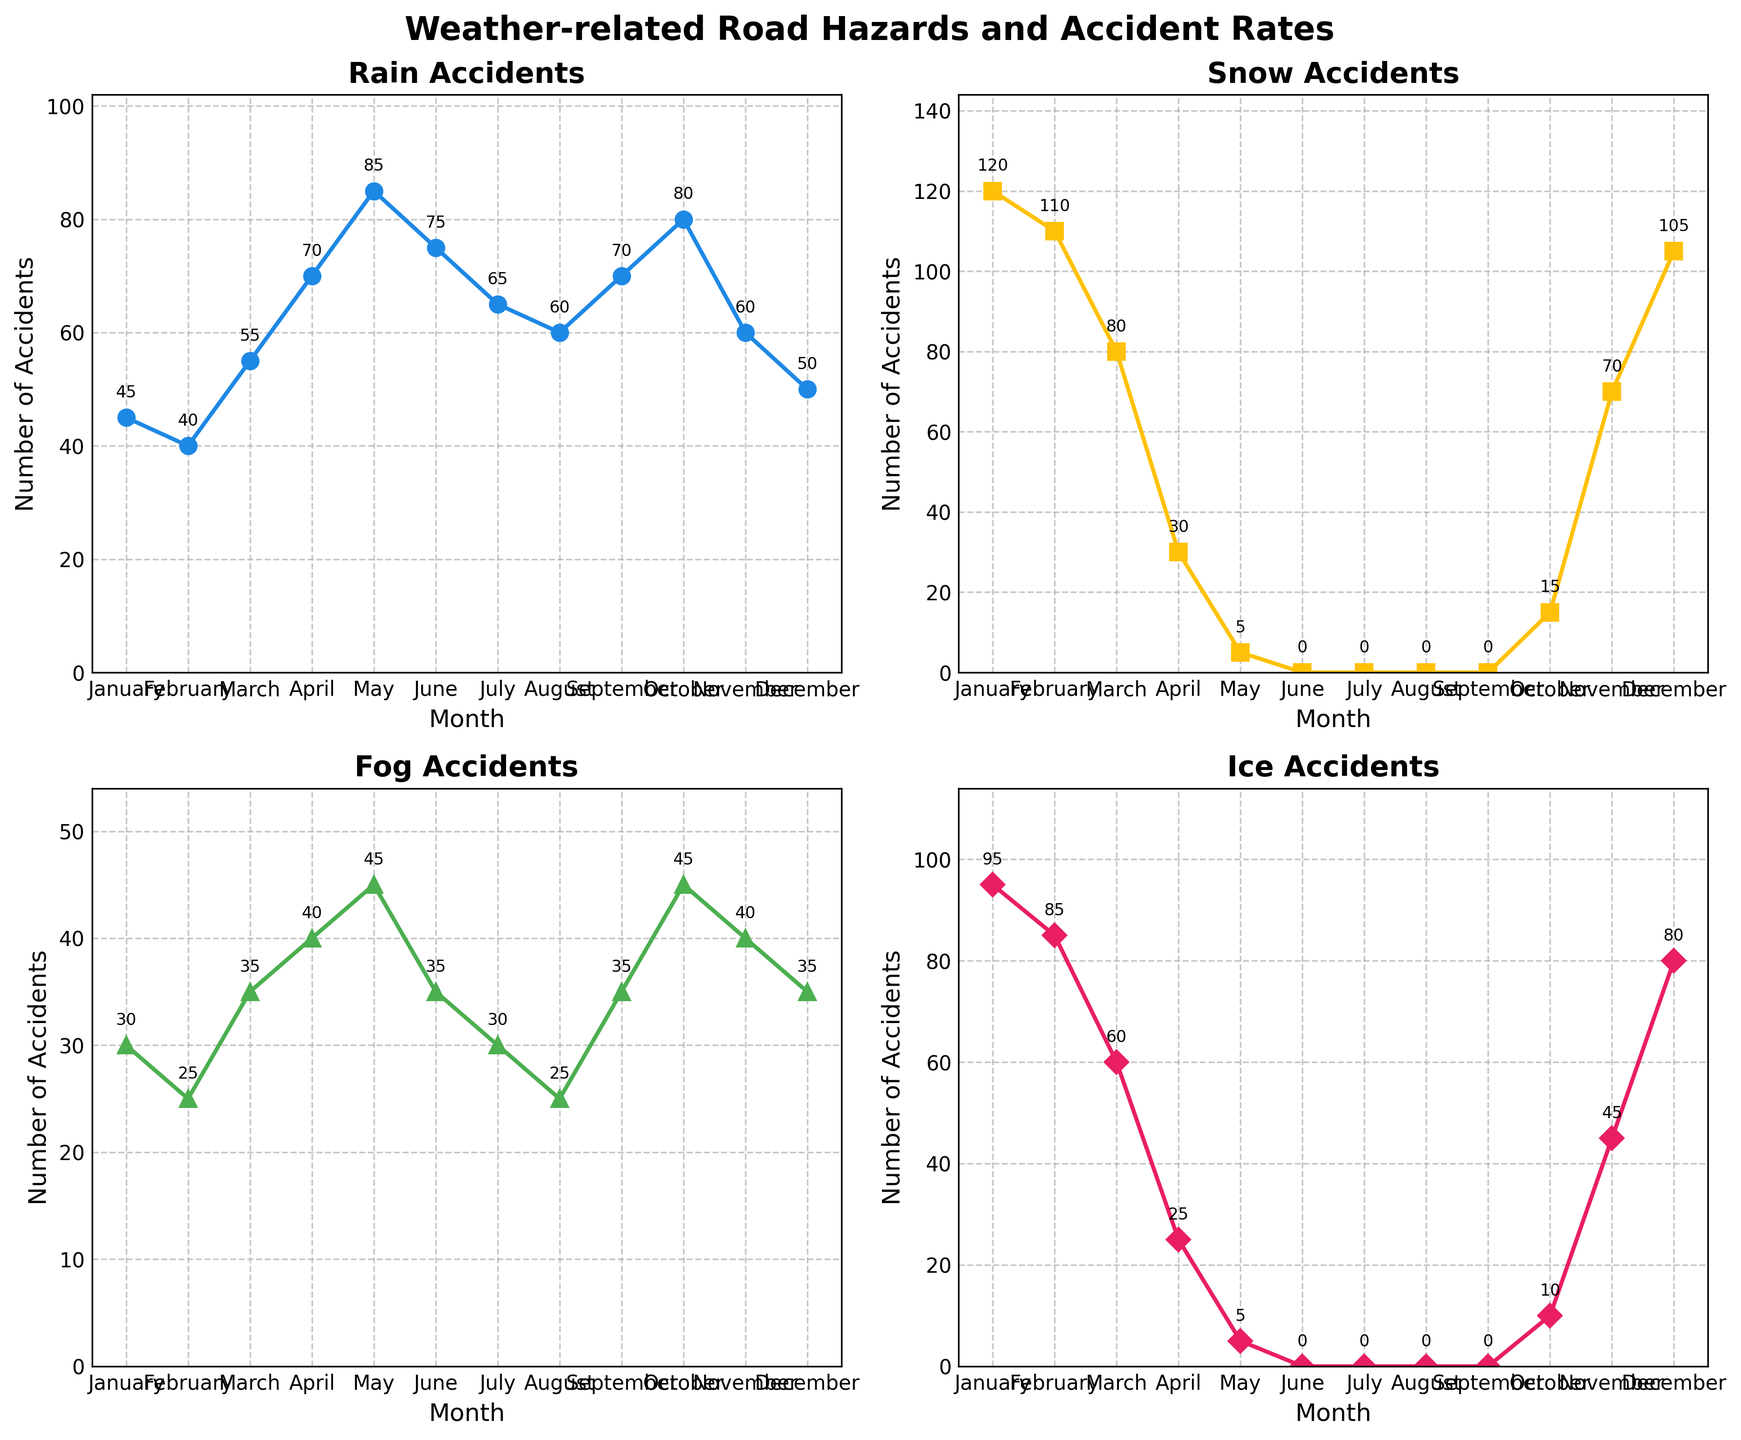What title is given to the figure? The title is written at the top of the figure. It reads "Weather-related Road Hazards and Accident Rates".
Answer: Weather-related Road Hazards and Accident Rates What month has the highest number of snow-related accidents? In the subplot titled "Snow Accidents," the line peaks in January, indicating this month has the highest number of snow-related accidents.
Answer: January How many fog-related accidents occurred in June? In the subplot titled "Fog Accidents," the data point for June is labeled with its value. It shows 35 fog-related accidents.
Answer: 35 Which month shows the least number of ice-related accidents? In the subplot titled "Ice Accidents," the lowest data points occur in the summer months (June, July, and August), with a value of 0 each.
Answer: June, July, August Compare the number of rain-related accidents in April and October. In the "Rain Accidents" subplot, April has 70 accidents, while October has 80. October has more rain-related accidents than April.
Answer: October has more What is the total number of fog-related accidents from January to December? Sum the number of fog-related accidents for each month: 30 + 25 + 35 + 40 + 45 + 35 + 30 + 25 + 35 + 45 + 40 + 35 = 420.
Answer: 420 How do the number of ice-related accidents in February and March compare? In the "Ice Accidents" subplot, February has 85 ice-related accidents, while March has 60. February has more ice-related accidents than March.
Answer: February has more Which hazard shows the lowest accidents in May? Compare the values for May across all subplots. "Snow Accidents" has the lowest with 5 accidents.
Answer: Snow Accidents What is the average number of rain-related accidents over the year? Add the rain accident numbers and divide by 12: (45 + 40 + 55 + 70 + 85 + 75 + 65 + 60 + 70 + 80 + 60 + 50) / 12 = 62.5.
Answer: 62.5 Which month has the lowest number of weather-related accidents for rain, snow, fog, and ice combined? Check each subplot and sum the accidents for each month. May has the lowest combined total: Rain (85) + Snow (5) + Fog (45) + Ice (5) = 140.
Answer: May 